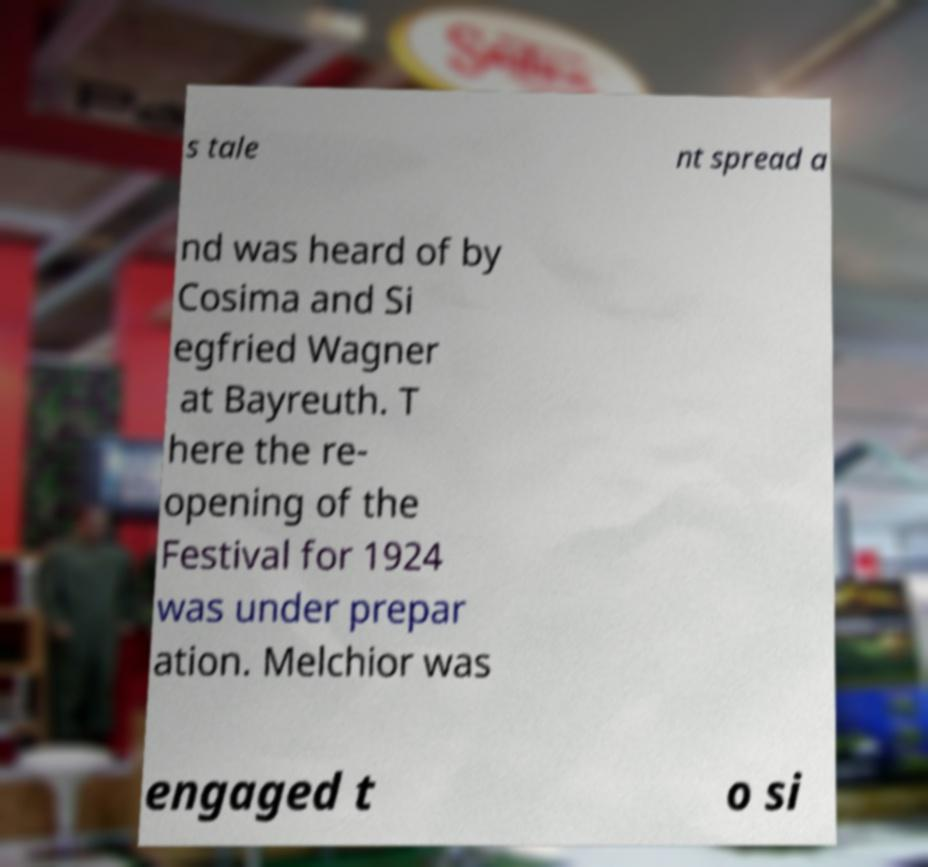Can you accurately transcribe the text from the provided image for me? s tale nt spread a nd was heard of by Cosima and Si egfried Wagner at Bayreuth. T here the re- opening of the Festival for 1924 was under prepar ation. Melchior was engaged t o si 